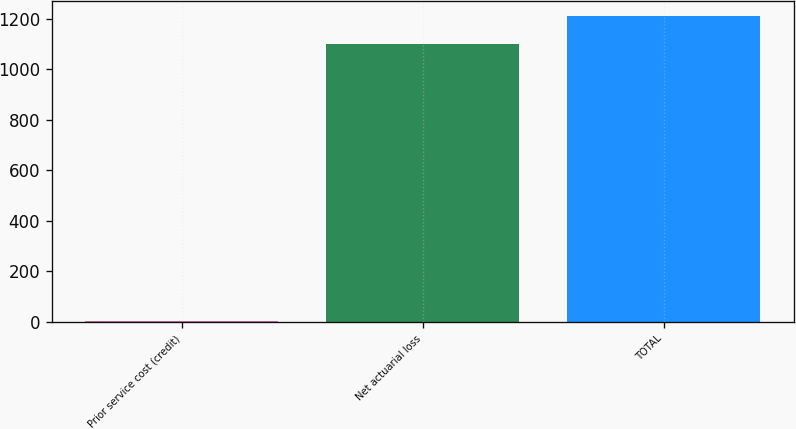<chart> <loc_0><loc_0><loc_500><loc_500><bar_chart><fcel>Prior service cost (credit)<fcel>Net actuarial loss<fcel>TOTAL<nl><fcel>3<fcel>1099.9<fcel>1209.89<nl></chart> 